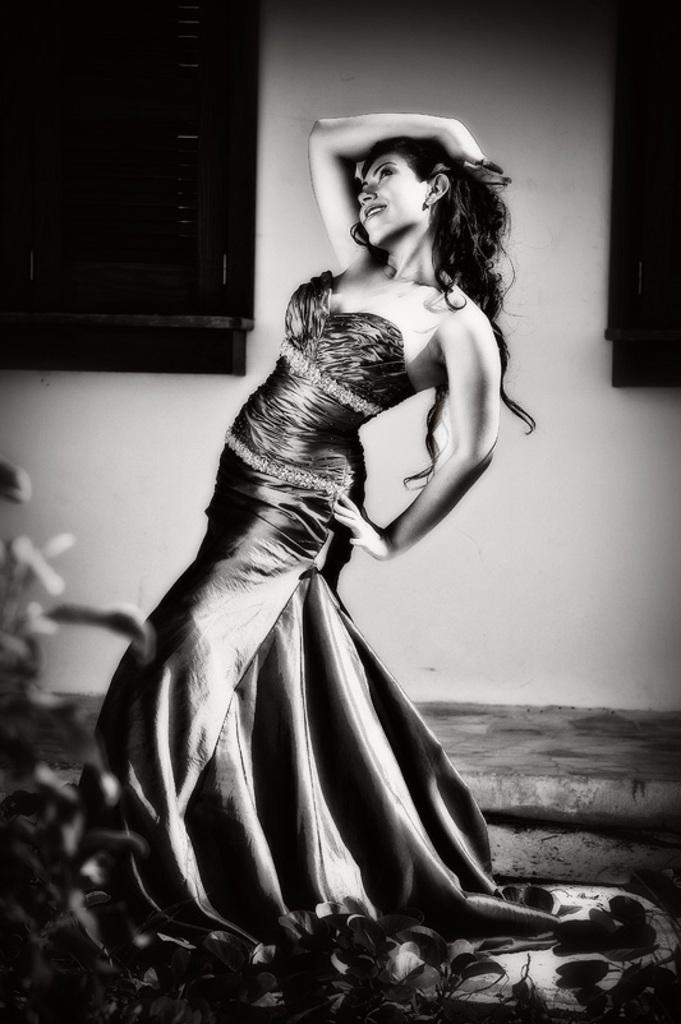Who is present in the image? There is a woman in the image. How is the woman positioned in the image? The woman is standing in a different posture. What is behind the woman in the image? There is a wall behind the woman. What is beside the wall in the image? There is a window beside the wall. What type of yarn is the girl using in the image? There is no girl or yarn present in the image; it features a woman standing in a different posture with a wall and window in the background. What type of brass instrument can be heard playing in the image? There is no brass instrument or sound present in the image. 